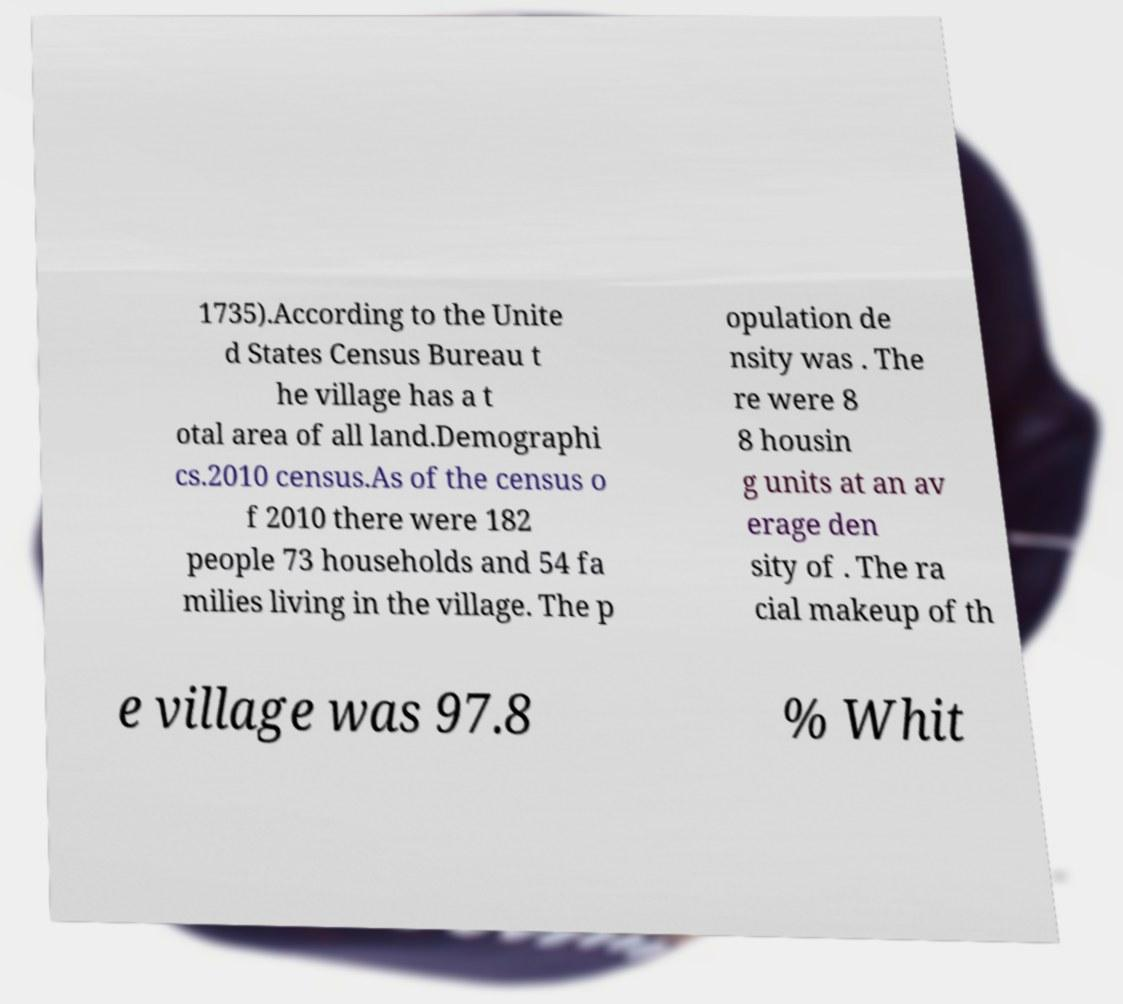Please identify and transcribe the text found in this image. 1735).According to the Unite d States Census Bureau t he village has a t otal area of all land.Demographi cs.2010 census.As of the census o f 2010 there were 182 people 73 households and 54 fa milies living in the village. The p opulation de nsity was . The re were 8 8 housin g units at an av erage den sity of . The ra cial makeup of th e village was 97.8 % Whit 